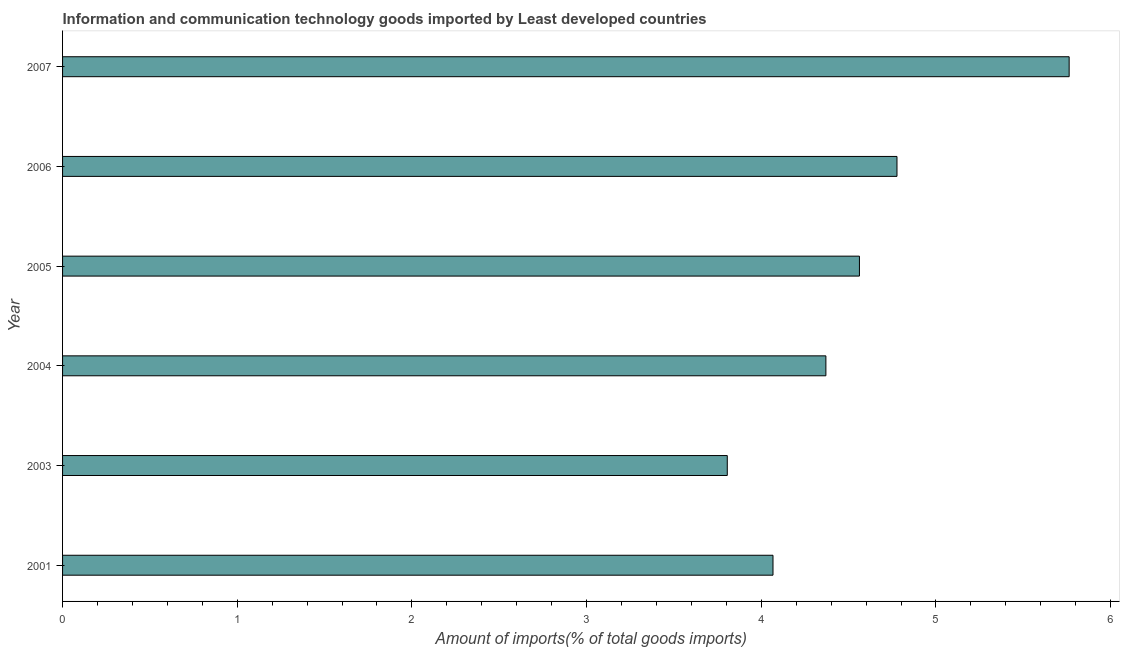Does the graph contain grids?
Provide a succinct answer. No. What is the title of the graph?
Provide a short and direct response. Information and communication technology goods imported by Least developed countries. What is the label or title of the X-axis?
Provide a succinct answer. Amount of imports(% of total goods imports). What is the label or title of the Y-axis?
Your answer should be compact. Year. What is the amount of ict goods imports in 2007?
Make the answer very short. 5.76. Across all years, what is the maximum amount of ict goods imports?
Your response must be concise. 5.76. Across all years, what is the minimum amount of ict goods imports?
Offer a terse response. 3.81. In which year was the amount of ict goods imports maximum?
Keep it short and to the point. 2007. What is the sum of the amount of ict goods imports?
Make the answer very short. 27.34. What is the difference between the amount of ict goods imports in 2005 and 2007?
Your answer should be very brief. -1.2. What is the average amount of ict goods imports per year?
Your answer should be very brief. 4.56. What is the median amount of ict goods imports?
Your response must be concise. 4.47. In how many years, is the amount of ict goods imports greater than 5.4 %?
Give a very brief answer. 1. Do a majority of the years between 2003 and 2006 (inclusive) have amount of ict goods imports greater than 1.8 %?
Offer a terse response. Yes. What is the ratio of the amount of ict goods imports in 2005 to that in 2006?
Ensure brevity in your answer.  0.95. Is the amount of ict goods imports in 2003 less than that in 2004?
Your response must be concise. Yes. Is the sum of the amount of ict goods imports in 2004 and 2007 greater than the maximum amount of ict goods imports across all years?
Ensure brevity in your answer.  Yes. What is the difference between the highest and the lowest amount of ict goods imports?
Your response must be concise. 1.96. How many years are there in the graph?
Make the answer very short. 6. What is the Amount of imports(% of total goods imports) in 2001?
Offer a terse response. 4.07. What is the Amount of imports(% of total goods imports) in 2003?
Your response must be concise. 3.81. What is the Amount of imports(% of total goods imports) of 2004?
Offer a terse response. 4.37. What is the Amount of imports(% of total goods imports) of 2005?
Provide a succinct answer. 4.56. What is the Amount of imports(% of total goods imports) in 2006?
Your answer should be very brief. 4.78. What is the Amount of imports(% of total goods imports) of 2007?
Your response must be concise. 5.76. What is the difference between the Amount of imports(% of total goods imports) in 2001 and 2003?
Offer a terse response. 0.26. What is the difference between the Amount of imports(% of total goods imports) in 2001 and 2004?
Your answer should be compact. -0.3. What is the difference between the Amount of imports(% of total goods imports) in 2001 and 2005?
Ensure brevity in your answer.  -0.49. What is the difference between the Amount of imports(% of total goods imports) in 2001 and 2006?
Keep it short and to the point. -0.71. What is the difference between the Amount of imports(% of total goods imports) in 2001 and 2007?
Offer a very short reply. -1.7. What is the difference between the Amount of imports(% of total goods imports) in 2003 and 2004?
Offer a very short reply. -0.56. What is the difference between the Amount of imports(% of total goods imports) in 2003 and 2005?
Provide a succinct answer. -0.76. What is the difference between the Amount of imports(% of total goods imports) in 2003 and 2006?
Ensure brevity in your answer.  -0.97. What is the difference between the Amount of imports(% of total goods imports) in 2003 and 2007?
Offer a terse response. -1.96. What is the difference between the Amount of imports(% of total goods imports) in 2004 and 2005?
Give a very brief answer. -0.19. What is the difference between the Amount of imports(% of total goods imports) in 2004 and 2006?
Your answer should be compact. -0.41. What is the difference between the Amount of imports(% of total goods imports) in 2004 and 2007?
Offer a very short reply. -1.39. What is the difference between the Amount of imports(% of total goods imports) in 2005 and 2006?
Provide a succinct answer. -0.21. What is the difference between the Amount of imports(% of total goods imports) in 2005 and 2007?
Offer a very short reply. -1.2. What is the difference between the Amount of imports(% of total goods imports) in 2006 and 2007?
Keep it short and to the point. -0.99. What is the ratio of the Amount of imports(% of total goods imports) in 2001 to that in 2003?
Your answer should be very brief. 1.07. What is the ratio of the Amount of imports(% of total goods imports) in 2001 to that in 2005?
Make the answer very short. 0.89. What is the ratio of the Amount of imports(% of total goods imports) in 2001 to that in 2006?
Make the answer very short. 0.85. What is the ratio of the Amount of imports(% of total goods imports) in 2001 to that in 2007?
Ensure brevity in your answer.  0.71. What is the ratio of the Amount of imports(% of total goods imports) in 2003 to that in 2004?
Offer a very short reply. 0.87. What is the ratio of the Amount of imports(% of total goods imports) in 2003 to that in 2005?
Your answer should be very brief. 0.83. What is the ratio of the Amount of imports(% of total goods imports) in 2003 to that in 2006?
Make the answer very short. 0.8. What is the ratio of the Amount of imports(% of total goods imports) in 2003 to that in 2007?
Make the answer very short. 0.66. What is the ratio of the Amount of imports(% of total goods imports) in 2004 to that in 2005?
Your response must be concise. 0.96. What is the ratio of the Amount of imports(% of total goods imports) in 2004 to that in 2006?
Make the answer very short. 0.92. What is the ratio of the Amount of imports(% of total goods imports) in 2004 to that in 2007?
Make the answer very short. 0.76. What is the ratio of the Amount of imports(% of total goods imports) in 2005 to that in 2006?
Your response must be concise. 0.95. What is the ratio of the Amount of imports(% of total goods imports) in 2005 to that in 2007?
Make the answer very short. 0.79. What is the ratio of the Amount of imports(% of total goods imports) in 2006 to that in 2007?
Your response must be concise. 0.83. 